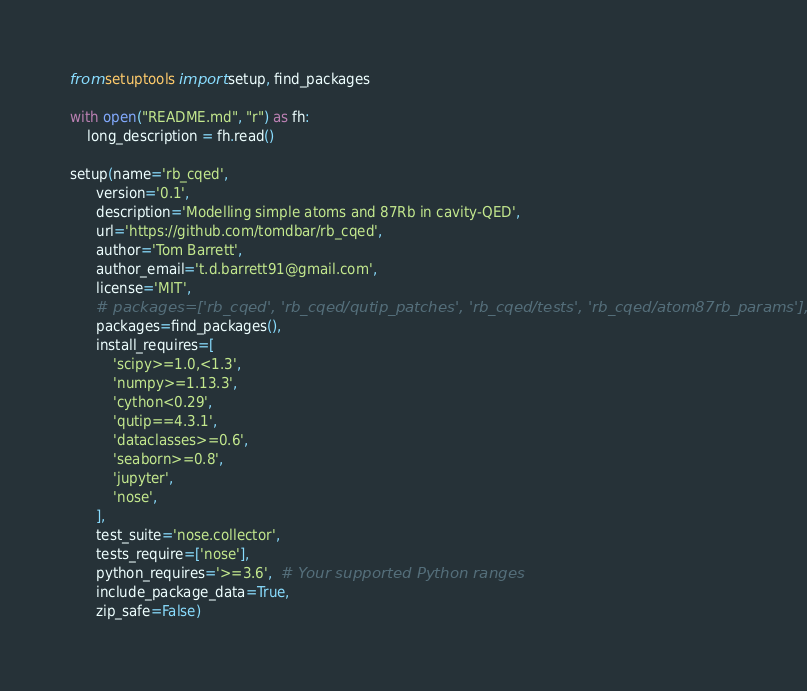<code> <loc_0><loc_0><loc_500><loc_500><_Python_>from setuptools import setup, find_packages

with open("README.md", "r") as fh:
    long_description = fh.read()

setup(name='rb_cqed',
      version='0.1',
      description='Modelling simple atoms and 87Rb in cavity-QED',
      url='https://github.com/tomdbar/rb_cqed',
      author='Tom Barrett',
      author_email='t.d.barrett91@gmail.com',
      license='MIT',
      # packages=['rb_cqed', 'rb_cqed/qutip_patches', 'rb_cqed/tests', 'rb_cqed/atom87rb_params'],
      packages=find_packages(),
      install_requires=[
          'scipy>=1.0,<1.3',
          'numpy>=1.13.3',
          'cython<0.29',
          'qutip==4.3.1',
          'dataclasses>=0.6',
          'seaborn>=0.8',
          'jupyter',
          'nose',
      ],
      test_suite='nose.collector',
      tests_require=['nose'],
      python_requires='>=3.6',  # Your supported Python ranges
      include_package_data=True,
      zip_safe=False)
</code> 